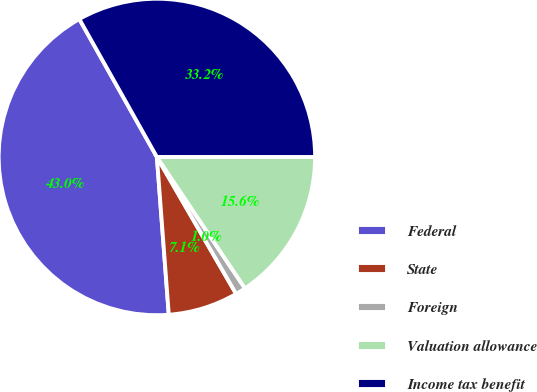Convert chart to OTSL. <chart><loc_0><loc_0><loc_500><loc_500><pie_chart><fcel>Federal<fcel>State<fcel>Foreign<fcel>Valuation allowance<fcel>Income tax benefit<nl><fcel>43.05%<fcel>7.15%<fcel>1.05%<fcel>15.6%<fcel>33.16%<nl></chart> 